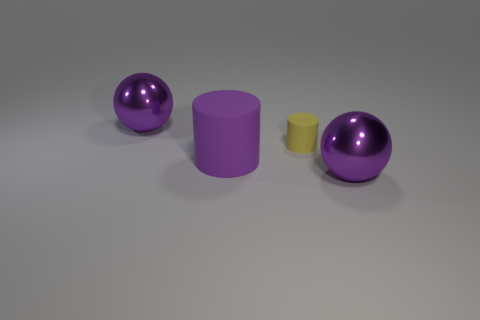Add 1 rubber cylinders. How many objects exist? 5 Subtract all red spheres. Subtract all cyan blocks. How many spheres are left? 2 Subtract all shiny spheres. Subtract all large purple rubber objects. How many objects are left? 1 Add 1 yellow objects. How many yellow objects are left? 2 Add 1 purple rubber things. How many purple rubber things exist? 2 Subtract 0 cyan cylinders. How many objects are left? 4 